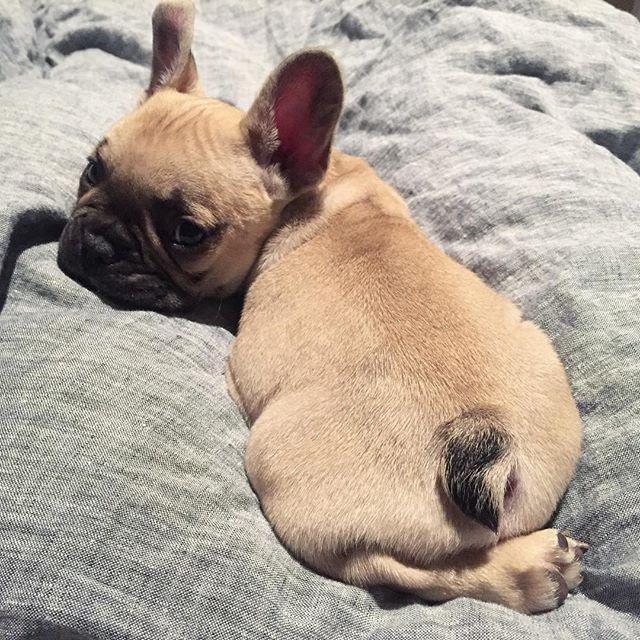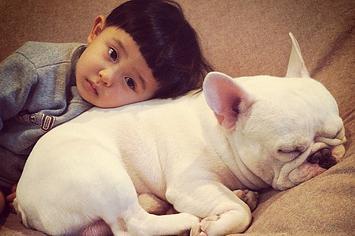The first image is the image on the left, the second image is the image on the right. For the images displayed, is the sentence "A young person is lying with at least one dog." factually correct? Answer yes or no. Yes. The first image is the image on the left, the second image is the image on the right. Examine the images to the left and right. Is the description "An image shows a human child resting with at least one snoozing dog." accurate? Answer yes or no. Yes. 